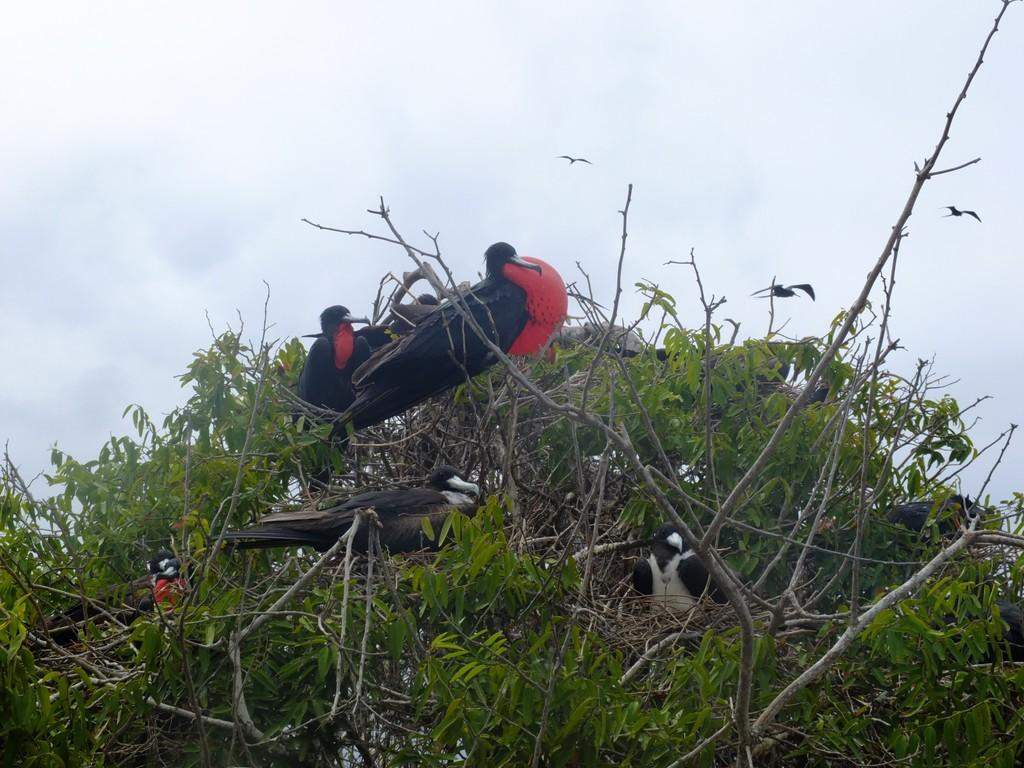What type of animals can be seen in the image? There are birds in the image. Where are the birds located? The birds are in nests in the image. What is the birds' habitat in the image? The nests are on a tree in the image. Can you describe the tree in the image? The tree has leaves and branches in the image. What type of card can be seen floating in the waves near the tree in the image? There is no card or waves present in the image; it features birds in nests on a tree with leaves and branches. Can you tell me how many dinosaurs are visible in the image? There are no dinosaurs present in the image; it features birds in nests on a tree with leaves and branches. 